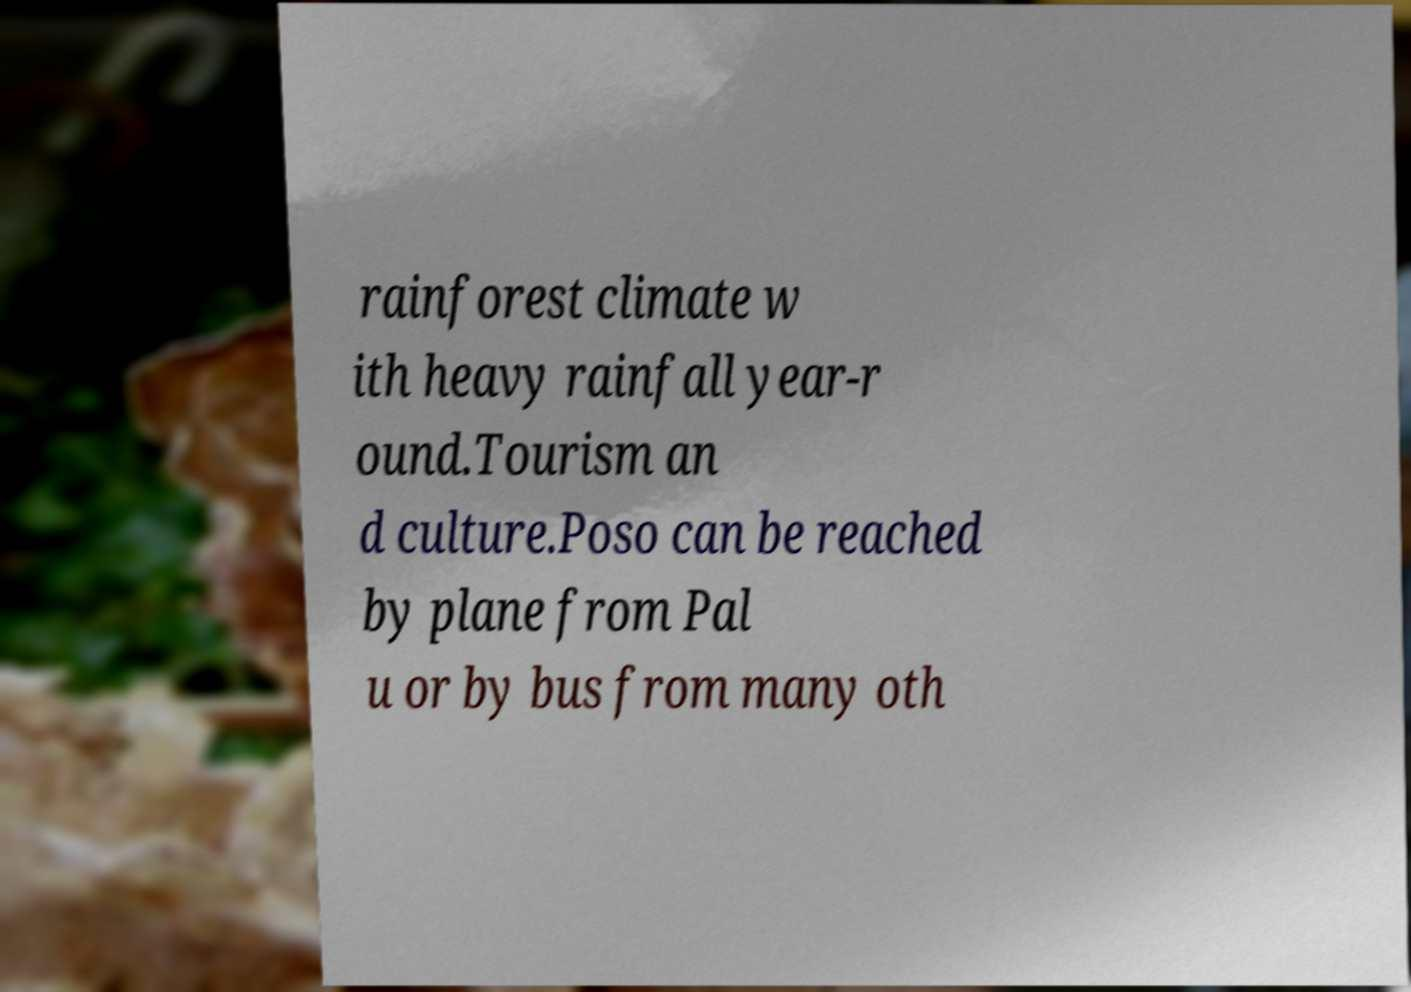What messages or text are displayed in this image? I need them in a readable, typed format. rainforest climate w ith heavy rainfall year-r ound.Tourism an d culture.Poso can be reached by plane from Pal u or by bus from many oth 